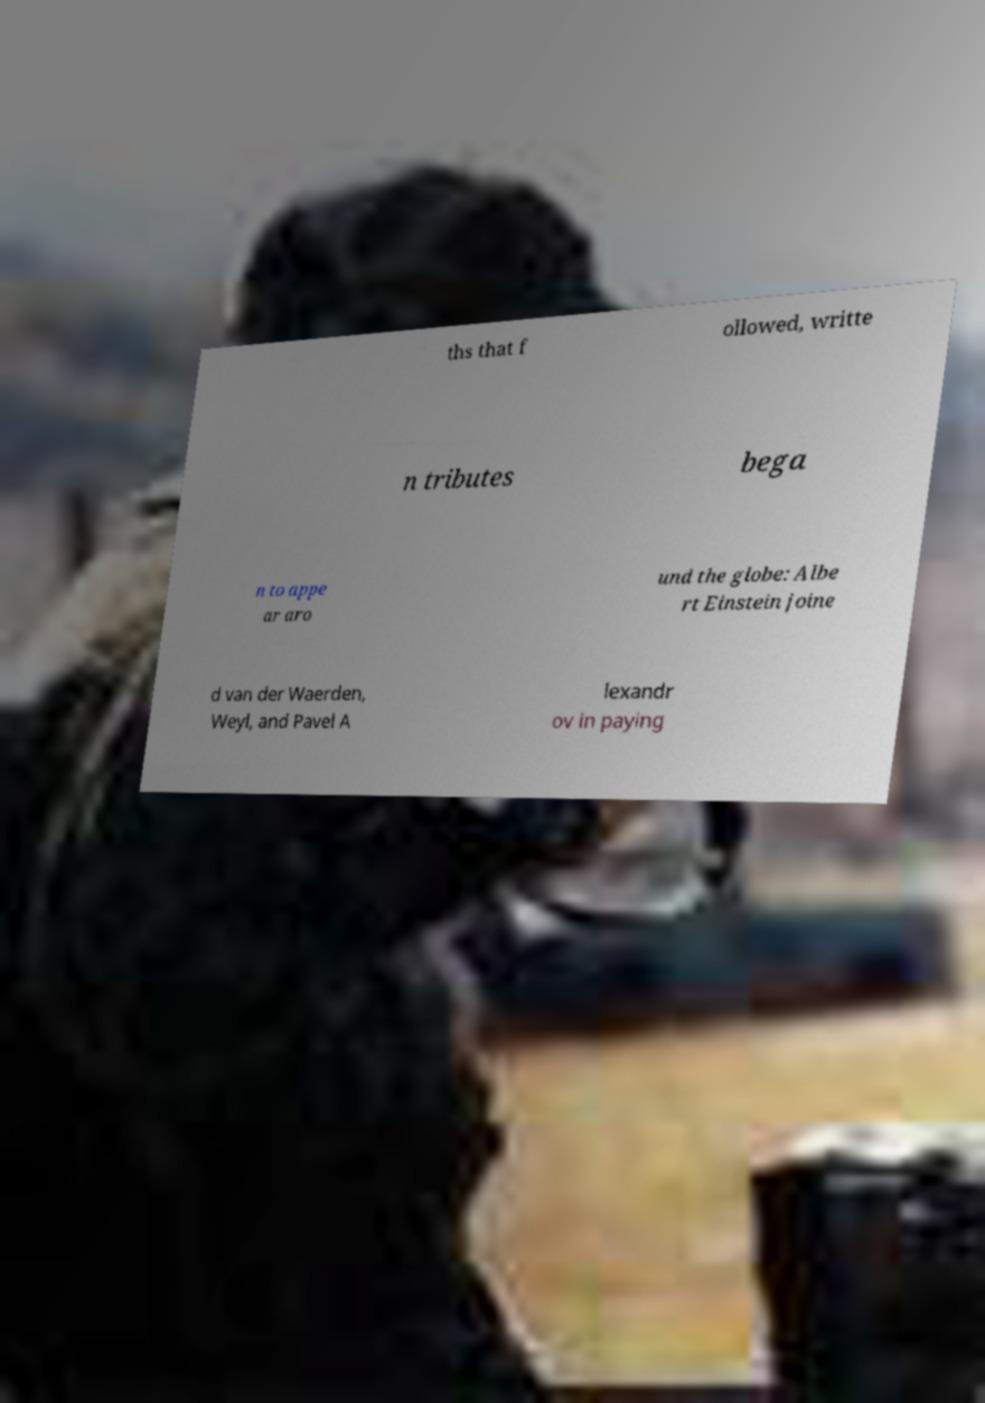For documentation purposes, I need the text within this image transcribed. Could you provide that? ths that f ollowed, writte n tributes bega n to appe ar aro und the globe: Albe rt Einstein joine d van der Waerden, Weyl, and Pavel A lexandr ov in paying 